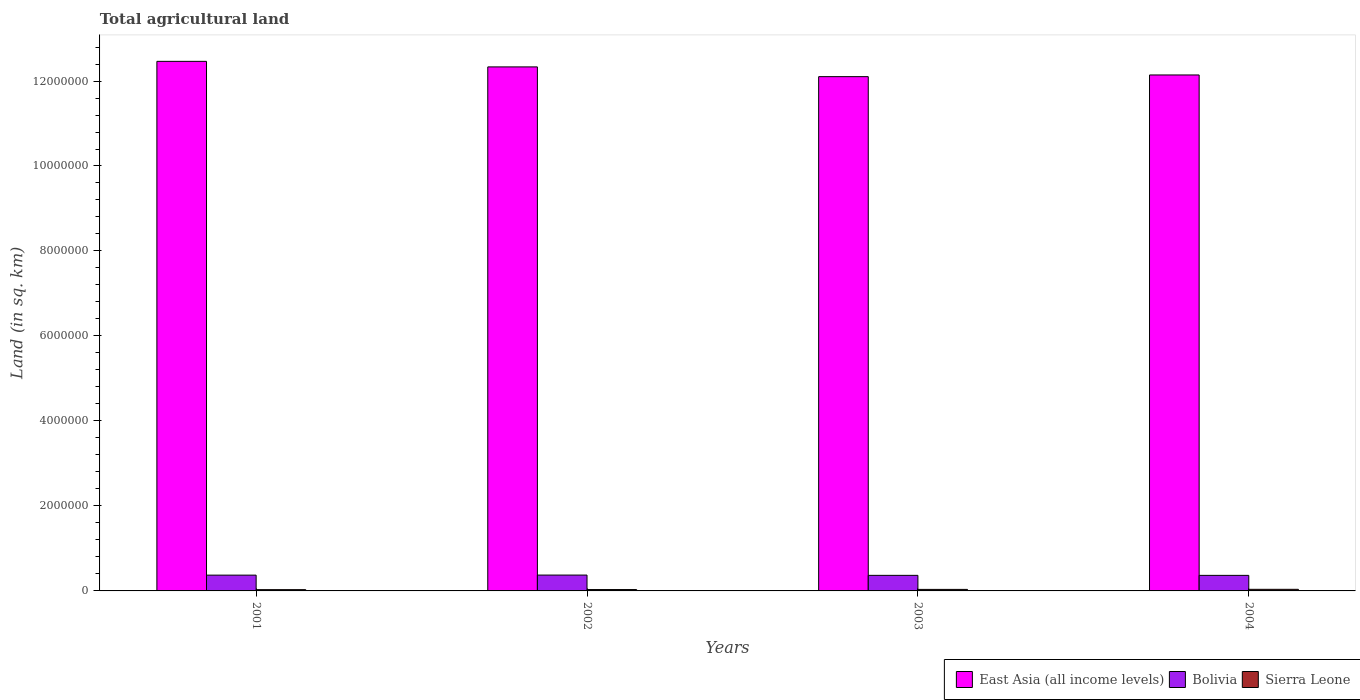Are the number of bars per tick equal to the number of legend labels?
Your response must be concise. Yes. How many bars are there on the 4th tick from the left?
Keep it short and to the point. 3. What is the total agricultural land in Bolivia in 2002?
Your answer should be compact. 3.73e+05. Across all years, what is the maximum total agricultural land in Bolivia?
Provide a short and direct response. 3.73e+05. Across all years, what is the minimum total agricultural land in East Asia (all income levels)?
Offer a terse response. 1.21e+07. In which year was the total agricultural land in Bolivia maximum?
Keep it short and to the point. 2002. In which year was the total agricultural land in East Asia (all income levels) minimum?
Give a very brief answer. 2003. What is the total total agricultural land in Bolivia in the graph?
Give a very brief answer. 1.48e+06. What is the difference between the total agricultural land in Bolivia in 2001 and that in 2002?
Your answer should be very brief. -1550. What is the difference between the total agricultural land in Sierra Leone in 2003 and the total agricultural land in East Asia (all income levels) in 2004?
Your response must be concise. -1.21e+07. What is the average total agricultural land in Sierra Leone per year?
Offer a very short reply. 3.39e+04. In the year 2003, what is the difference between the total agricultural land in Bolivia and total agricultural land in Sierra Leone?
Offer a terse response. 3.31e+05. In how many years, is the total agricultural land in East Asia (all income levels) greater than 6800000 sq.km?
Offer a very short reply. 4. What is the ratio of the total agricultural land in Bolivia in 2001 to that in 2002?
Keep it short and to the point. 1. Is the difference between the total agricultural land in Bolivia in 2001 and 2004 greater than the difference between the total agricultural land in Sierra Leone in 2001 and 2004?
Your answer should be very brief. Yes. What is the difference between the highest and the second highest total agricultural land in Bolivia?
Your response must be concise. 1550. What is the difference between the highest and the lowest total agricultural land in East Asia (all income levels)?
Offer a very short reply. 3.60e+05. What does the 1st bar from the left in 2001 represents?
Provide a short and direct response. East Asia (all income levels). What does the 1st bar from the right in 2001 represents?
Give a very brief answer. Sierra Leone. What is the difference between two consecutive major ticks on the Y-axis?
Your answer should be compact. 2.00e+06. Does the graph contain grids?
Offer a terse response. No. What is the title of the graph?
Provide a succinct answer. Total agricultural land. Does "Small states" appear as one of the legend labels in the graph?
Provide a succinct answer. No. What is the label or title of the Y-axis?
Ensure brevity in your answer.  Land (in sq. km). What is the Land (in sq. km) in East Asia (all income levels) in 2001?
Provide a succinct answer. 1.25e+07. What is the Land (in sq. km) in Bolivia in 2001?
Make the answer very short. 3.72e+05. What is the Land (in sq. km) in Sierra Leone in 2001?
Your answer should be compact. 3.00e+04. What is the Land (in sq. km) of East Asia (all income levels) in 2002?
Provide a short and direct response. 1.23e+07. What is the Land (in sq. km) of Bolivia in 2002?
Give a very brief answer. 3.73e+05. What is the Land (in sq. km) in Sierra Leone in 2002?
Make the answer very short. 3.23e+04. What is the Land (in sq. km) in East Asia (all income levels) in 2003?
Your response must be concise. 1.21e+07. What is the Land (in sq. km) of Bolivia in 2003?
Provide a succinct answer. 3.66e+05. What is the Land (in sq. km) of Sierra Leone in 2003?
Your response must be concise. 3.57e+04. What is the Land (in sq. km) in East Asia (all income levels) in 2004?
Offer a terse response. 1.21e+07. What is the Land (in sq. km) of Bolivia in 2004?
Provide a succinct answer. 3.66e+05. What is the Land (in sq. km) in Sierra Leone in 2004?
Ensure brevity in your answer.  3.77e+04. Across all years, what is the maximum Land (in sq. km) in East Asia (all income levels)?
Your answer should be very brief. 1.25e+07. Across all years, what is the maximum Land (in sq. km) of Bolivia?
Provide a short and direct response. 3.73e+05. Across all years, what is the maximum Land (in sq. km) in Sierra Leone?
Your answer should be very brief. 3.77e+04. Across all years, what is the minimum Land (in sq. km) of East Asia (all income levels)?
Offer a terse response. 1.21e+07. Across all years, what is the minimum Land (in sq. km) of Bolivia?
Your answer should be very brief. 3.66e+05. Across all years, what is the minimum Land (in sq. km) of Sierra Leone?
Provide a short and direct response. 3.00e+04. What is the total Land (in sq. km) of East Asia (all income levels) in the graph?
Your response must be concise. 4.90e+07. What is the total Land (in sq. km) in Bolivia in the graph?
Ensure brevity in your answer.  1.48e+06. What is the total Land (in sq. km) of Sierra Leone in the graph?
Your answer should be compact. 1.36e+05. What is the difference between the Land (in sq. km) of East Asia (all income levels) in 2001 and that in 2002?
Ensure brevity in your answer.  1.31e+05. What is the difference between the Land (in sq. km) of Bolivia in 2001 and that in 2002?
Provide a short and direct response. -1550. What is the difference between the Land (in sq. km) of Sierra Leone in 2001 and that in 2002?
Your response must be concise. -2285.6. What is the difference between the Land (in sq. km) in East Asia (all income levels) in 2001 and that in 2003?
Offer a very short reply. 3.60e+05. What is the difference between the Land (in sq. km) in Bolivia in 2001 and that in 2003?
Offer a very short reply. 5090. What is the difference between the Land (in sq. km) of Sierra Leone in 2001 and that in 2003?
Keep it short and to the point. -5651.5. What is the difference between the Land (in sq. km) of East Asia (all income levels) in 2001 and that in 2004?
Offer a terse response. 3.20e+05. What is the difference between the Land (in sq. km) of Bolivia in 2001 and that in 2004?
Make the answer very short. 5390. What is the difference between the Land (in sq. km) in Sierra Leone in 2001 and that in 2004?
Offer a very short reply. -7712.1. What is the difference between the Land (in sq. km) in East Asia (all income levels) in 2002 and that in 2003?
Give a very brief answer. 2.29e+05. What is the difference between the Land (in sq. km) of Bolivia in 2002 and that in 2003?
Give a very brief answer. 6640. What is the difference between the Land (in sq. km) in Sierra Leone in 2002 and that in 2003?
Provide a short and direct response. -3365.9. What is the difference between the Land (in sq. km) of East Asia (all income levels) in 2002 and that in 2004?
Your answer should be compact. 1.90e+05. What is the difference between the Land (in sq. km) of Bolivia in 2002 and that in 2004?
Keep it short and to the point. 6940. What is the difference between the Land (in sq. km) in Sierra Leone in 2002 and that in 2004?
Make the answer very short. -5426.5. What is the difference between the Land (in sq. km) in East Asia (all income levels) in 2003 and that in 2004?
Your answer should be compact. -3.95e+04. What is the difference between the Land (in sq. km) of Bolivia in 2003 and that in 2004?
Offer a terse response. 300. What is the difference between the Land (in sq. km) in Sierra Leone in 2003 and that in 2004?
Give a very brief answer. -2060.6. What is the difference between the Land (in sq. km) of East Asia (all income levels) in 2001 and the Land (in sq. km) of Bolivia in 2002?
Provide a succinct answer. 1.21e+07. What is the difference between the Land (in sq. km) in East Asia (all income levels) in 2001 and the Land (in sq. km) in Sierra Leone in 2002?
Provide a succinct answer. 1.24e+07. What is the difference between the Land (in sq. km) in Bolivia in 2001 and the Land (in sq. km) in Sierra Leone in 2002?
Give a very brief answer. 3.39e+05. What is the difference between the Land (in sq. km) of East Asia (all income levels) in 2001 and the Land (in sq. km) of Bolivia in 2003?
Ensure brevity in your answer.  1.21e+07. What is the difference between the Land (in sq. km) in East Asia (all income levels) in 2001 and the Land (in sq. km) in Sierra Leone in 2003?
Provide a short and direct response. 1.24e+07. What is the difference between the Land (in sq. km) of Bolivia in 2001 and the Land (in sq. km) of Sierra Leone in 2003?
Offer a terse response. 3.36e+05. What is the difference between the Land (in sq. km) in East Asia (all income levels) in 2001 and the Land (in sq. km) in Bolivia in 2004?
Keep it short and to the point. 1.21e+07. What is the difference between the Land (in sq. km) in East Asia (all income levels) in 2001 and the Land (in sq. km) in Sierra Leone in 2004?
Your response must be concise. 1.24e+07. What is the difference between the Land (in sq. km) in Bolivia in 2001 and the Land (in sq. km) in Sierra Leone in 2004?
Give a very brief answer. 3.34e+05. What is the difference between the Land (in sq. km) in East Asia (all income levels) in 2002 and the Land (in sq. km) in Bolivia in 2003?
Keep it short and to the point. 1.20e+07. What is the difference between the Land (in sq. km) of East Asia (all income levels) in 2002 and the Land (in sq. km) of Sierra Leone in 2003?
Your answer should be compact. 1.23e+07. What is the difference between the Land (in sq. km) of Bolivia in 2002 and the Land (in sq. km) of Sierra Leone in 2003?
Provide a short and direct response. 3.37e+05. What is the difference between the Land (in sq. km) in East Asia (all income levels) in 2002 and the Land (in sq. km) in Bolivia in 2004?
Your answer should be compact. 1.20e+07. What is the difference between the Land (in sq. km) of East Asia (all income levels) in 2002 and the Land (in sq. km) of Sierra Leone in 2004?
Your response must be concise. 1.23e+07. What is the difference between the Land (in sq. km) of Bolivia in 2002 and the Land (in sq. km) of Sierra Leone in 2004?
Your answer should be compact. 3.35e+05. What is the difference between the Land (in sq. km) of East Asia (all income levels) in 2003 and the Land (in sq. km) of Bolivia in 2004?
Make the answer very short. 1.17e+07. What is the difference between the Land (in sq. km) in East Asia (all income levels) in 2003 and the Land (in sq. km) in Sierra Leone in 2004?
Ensure brevity in your answer.  1.21e+07. What is the difference between the Land (in sq. km) in Bolivia in 2003 and the Land (in sq. km) in Sierra Leone in 2004?
Give a very brief answer. 3.29e+05. What is the average Land (in sq. km) of East Asia (all income levels) per year?
Your response must be concise. 1.23e+07. What is the average Land (in sq. km) of Bolivia per year?
Give a very brief answer. 3.69e+05. What is the average Land (in sq. km) in Sierra Leone per year?
Give a very brief answer. 3.39e+04. In the year 2001, what is the difference between the Land (in sq. km) in East Asia (all income levels) and Land (in sq. km) in Bolivia?
Offer a very short reply. 1.21e+07. In the year 2001, what is the difference between the Land (in sq. km) of East Asia (all income levels) and Land (in sq. km) of Sierra Leone?
Make the answer very short. 1.24e+07. In the year 2001, what is the difference between the Land (in sq. km) of Bolivia and Land (in sq. km) of Sierra Leone?
Make the answer very short. 3.42e+05. In the year 2002, what is the difference between the Land (in sq. km) of East Asia (all income levels) and Land (in sq. km) of Bolivia?
Make the answer very short. 1.20e+07. In the year 2002, what is the difference between the Land (in sq. km) of East Asia (all income levels) and Land (in sq. km) of Sierra Leone?
Offer a very short reply. 1.23e+07. In the year 2002, what is the difference between the Land (in sq. km) in Bolivia and Land (in sq. km) in Sierra Leone?
Your answer should be very brief. 3.41e+05. In the year 2003, what is the difference between the Land (in sq. km) of East Asia (all income levels) and Land (in sq. km) of Bolivia?
Your answer should be compact. 1.17e+07. In the year 2003, what is the difference between the Land (in sq. km) of East Asia (all income levels) and Land (in sq. km) of Sierra Leone?
Your response must be concise. 1.21e+07. In the year 2003, what is the difference between the Land (in sq. km) in Bolivia and Land (in sq. km) in Sierra Leone?
Make the answer very short. 3.31e+05. In the year 2004, what is the difference between the Land (in sq. km) in East Asia (all income levels) and Land (in sq. km) in Bolivia?
Your answer should be very brief. 1.18e+07. In the year 2004, what is the difference between the Land (in sq. km) in East Asia (all income levels) and Land (in sq. km) in Sierra Leone?
Ensure brevity in your answer.  1.21e+07. In the year 2004, what is the difference between the Land (in sq. km) in Bolivia and Land (in sq. km) in Sierra Leone?
Your response must be concise. 3.28e+05. What is the ratio of the Land (in sq. km) of East Asia (all income levels) in 2001 to that in 2002?
Your response must be concise. 1.01. What is the ratio of the Land (in sq. km) in Bolivia in 2001 to that in 2002?
Ensure brevity in your answer.  1. What is the ratio of the Land (in sq. km) of Sierra Leone in 2001 to that in 2002?
Ensure brevity in your answer.  0.93. What is the ratio of the Land (in sq. km) in East Asia (all income levels) in 2001 to that in 2003?
Offer a terse response. 1.03. What is the ratio of the Land (in sq. km) in Bolivia in 2001 to that in 2003?
Your response must be concise. 1.01. What is the ratio of the Land (in sq. km) of Sierra Leone in 2001 to that in 2003?
Your answer should be very brief. 0.84. What is the ratio of the Land (in sq. km) in East Asia (all income levels) in 2001 to that in 2004?
Your answer should be compact. 1.03. What is the ratio of the Land (in sq. km) of Bolivia in 2001 to that in 2004?
Offer a terse response. 1.01. What is the ratio of the Land (in sq. km) in Sierra Leone in 2001 to that in 2004?
Keep it short and to the point. 0.8. What is the ratio of the Land (in sq. km) of East Asia (all income levels) in 2002 to that in 2003?
Offer a very short reply. 1.02. What is the ratio of the Land (in sq. km) in Bolivia in 2002 to that in 2003?
Keep it short and to the point. 1.02. What is the ratio of the Land (in sq. km) in Sierra Leone in 2002 to that in 2003?
Offer a very short reply. 0.91. What is the ratio of the Land (in sq. km) of East Asia (all income levels) in 2002 to that in 2004?
Make the answer very short. 1.02. What is the ratio of the Land (in sq. km) in Sierra Leone in 2002 to that in 2004?
Offer a very short reply. 0.86. What is the ratio of the Land (in sq. km) in Sierra Leone in 2003 to that in 2004?
Keep it short and to the point. 0.95. What is the difference between the highest and the second highest Land (in sq. km) in East Asia (all income levels)?
Provide a succinct answer. 1.31e+05. What is the difference between the highest and the second highest Land (in sq. km) in Bolivia?
Offer a very short reply. 1550. What is the difference between the highest and the second highest Land (in sq. km) in Sierra Leone?
Give a very brief answer. 2060.6. What is the difference between the highest and the lowest Land (in sq. km) of East Asia (all income levels)?
Provide a succinct answer. 3.60e+05. What is the difference between the highest and the lowest Land (in sq. km) in Bolivia?
Ensure brevity in your answer.  6940. What is the difference between the highest and the lowest Land (in sq. km) of Sierra Leone?
Give a very brief answer. 7712.1. 